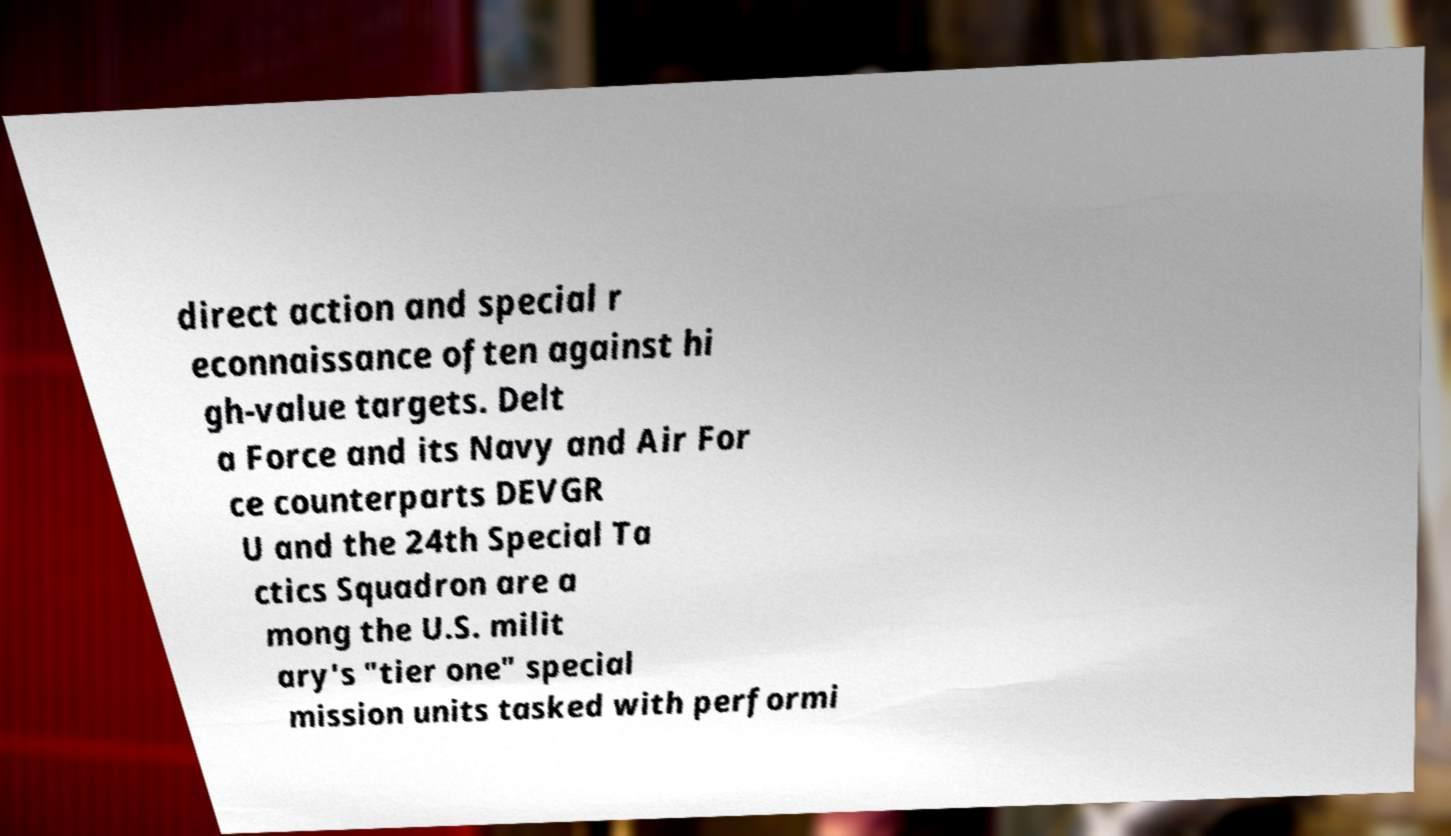Could you assist in decoding the text presented in this image and type it out clearly? direct action and special r econnaissance often against hi gh-value targets. Delt a Force and its Navy and Air For ce counterparts DEVGR U and the 24th Special Ta ctics Squadron are a mong the U.S. milit ary's "tier one" special mission units tasked with performi 